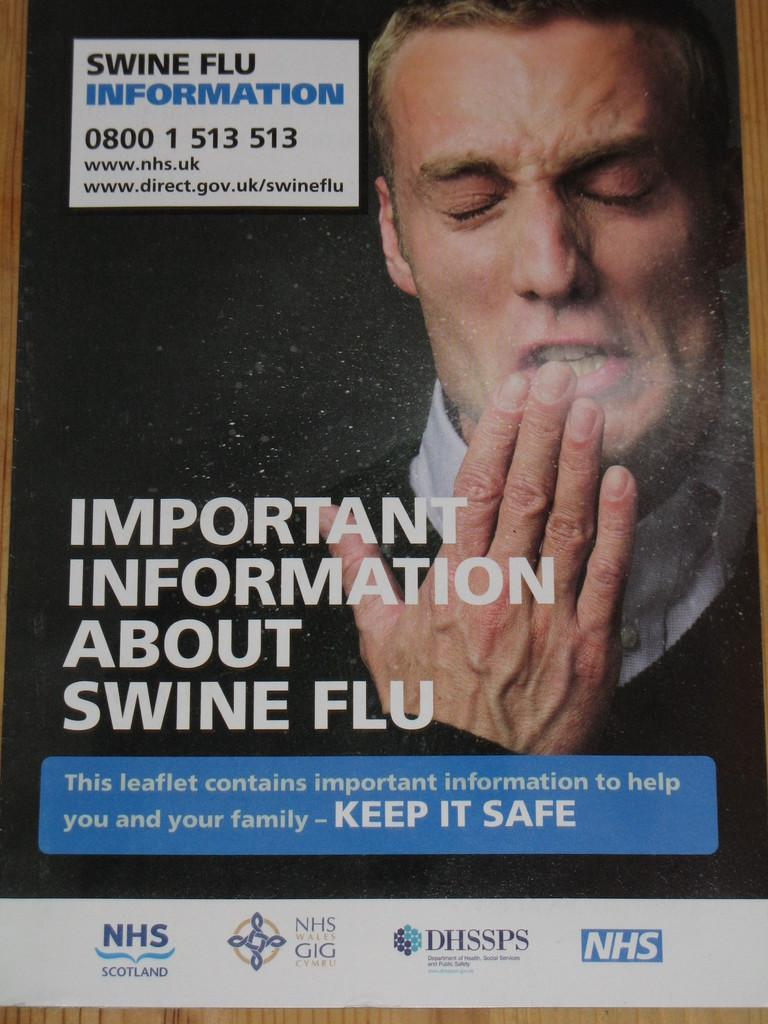What is the main object in the image? There is a poster in the image. What is depicted on the poster? The poster features a person. What else can be seen on the poster besides the person? There is text printed on the poster. What type of beast can be seen laughing in the image? There is no beast or laughter present in the image; it features a poster with a person and text. 